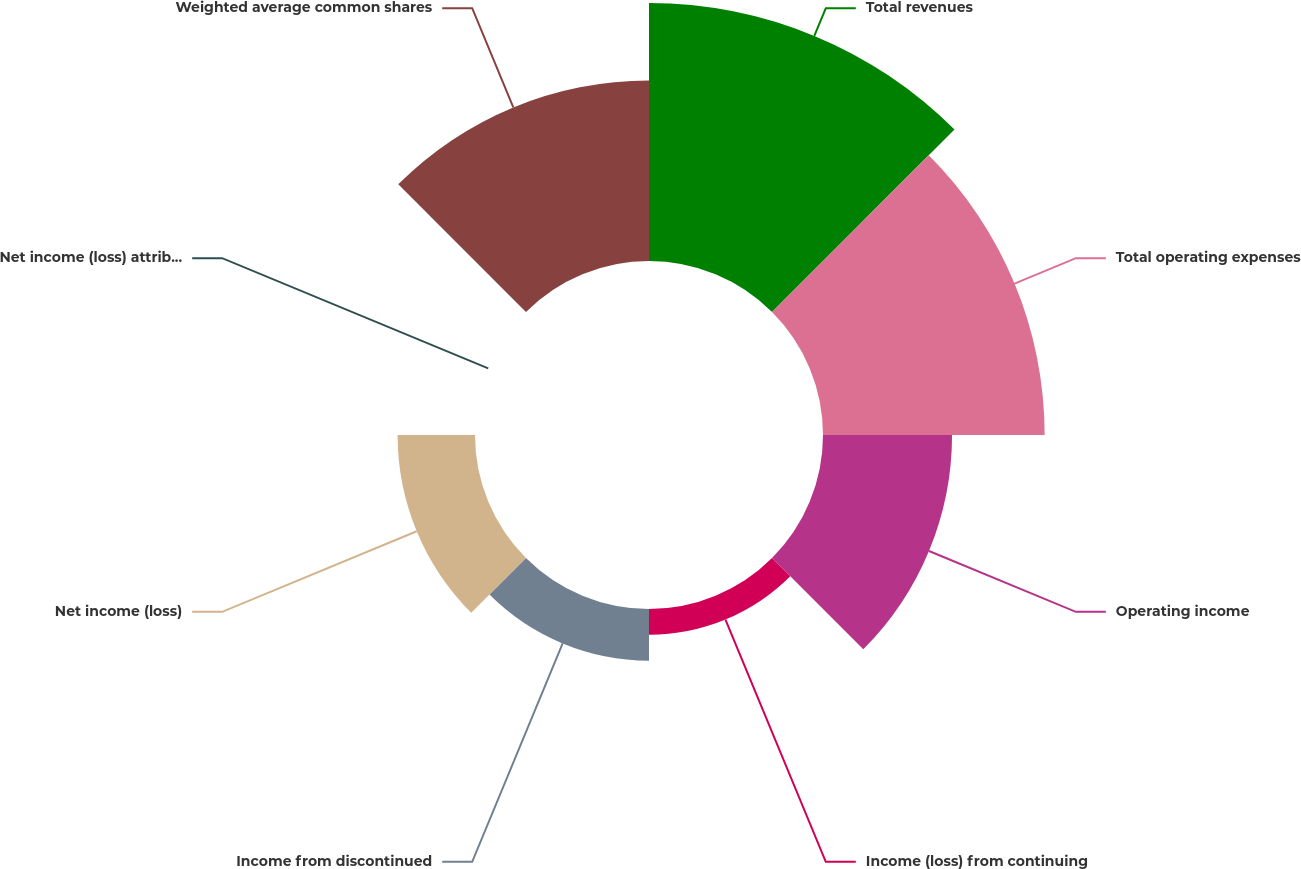Convert chart. <chart><loc_0><loc_0><loc_500><loc_500><pie_chart><fcel>Total revenues<fcel>Total operating expenses<fcel>Operating income<fcel>Income (loss) from continuing<fcel>Income from discontinued<fcel>Net income (loss)<fcel>Net income (loss) attributable<fcel>Weighted average common shares<nl><fcel>27.33%<fcel>23.48%<fcel>13.67%<fcel>2.73%<fcel>5.47%<fcel>8.2%<fcel>0.0%<fcel>19.13%<nl></chart> 